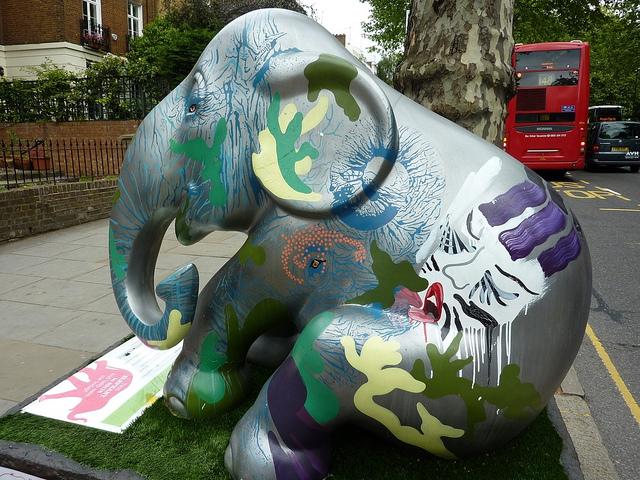Does the elephant need a bath?
Short answer required. No. What is the elephant sitting on?
Be succinct. Grass. What is the large red object in the background?
Quick response, please. Bus. 